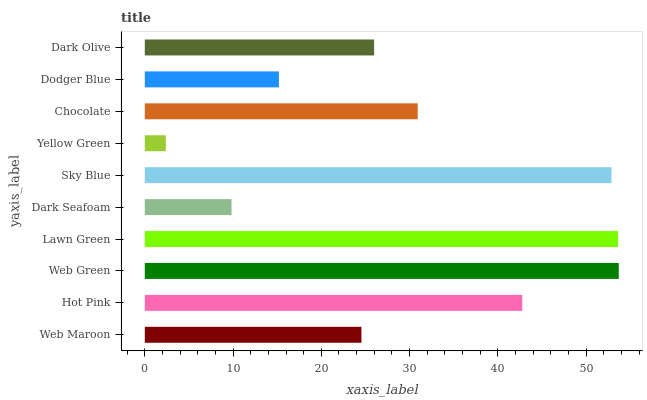Is Yellow Green the minimum?
Answer yes or no. Yes. Is Web Green the maximum?
Answer yes or no. Yes. Is Hot Pink the minimum?
Answer yes or no. No. Is Hot Pink the maximum?
Answer yes or no. No. Is Hot Pink greater than Web Maroon?
Answer yes or no. Yes. Is Web Maroon less than Hot Pink?
Answer yes or no. Yes. Is Web Maroon greater than Hot Pink?
Answer yes or no. No. Is Hot Pink less than Web Maroon?
Answer yes or no. No. Is Chocolate the high median?
Answer yes or no. Yes. Is Dark Olive the low median?
Answer yes or no. Yes. Is Web Maroon the high median?
Answer yes or no. No. Is Web Green the low median?
Answer yes or no. No. 